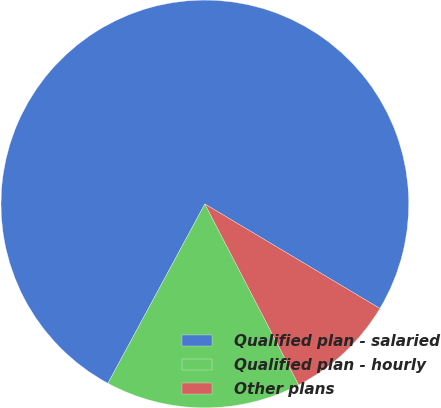Convert chart. <chart><loc_0><loc_0><loc_500><loc_500><pie_chart><fcel>Qualified plan - salaried<fcel>Qualified plan - hourly<fcel>Other plans<nl><fcel>75.68%<fcel>15.5%<fcel>8.82%<nl></chart> 